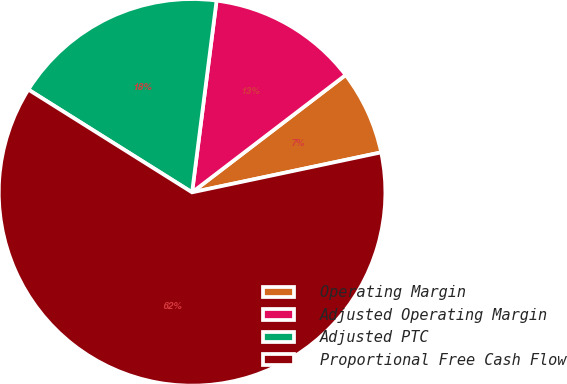Convert chart. <chart><loc_0><loc_0><loc_500><loc_500><pie_chart><fcel>Operating Margin<fcel>Adjusted Operating Margin<fcel>Adjusted PTC<fcel>Proportional Free Cash Flow<nl><fcel>7.07%<fcel>12.59%<fcel>18.1%<fcel>62.23%<nl></chart> 